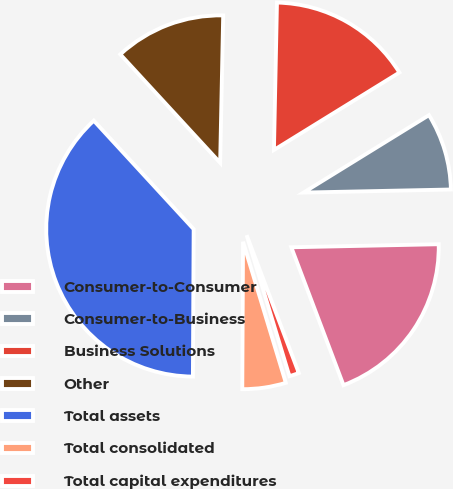Convert chart. <chart><loc_0><loc_0><loc_500><loc_500><pie_chart><fcel>Consumer-to-Consumer<fcel>Consumer-to-Business<fcel>Business Solutions<fcel>Other<fcel>Total assets<fcel>Total consolidated<fcel>Total capital expenditures<nl><fcel>19.57%<fcel>8.47%<fcel>15.87%<fcel>12.17%<fcel>38.07%<fcel>4.77%<fcel>1.07%<nl></chart> 